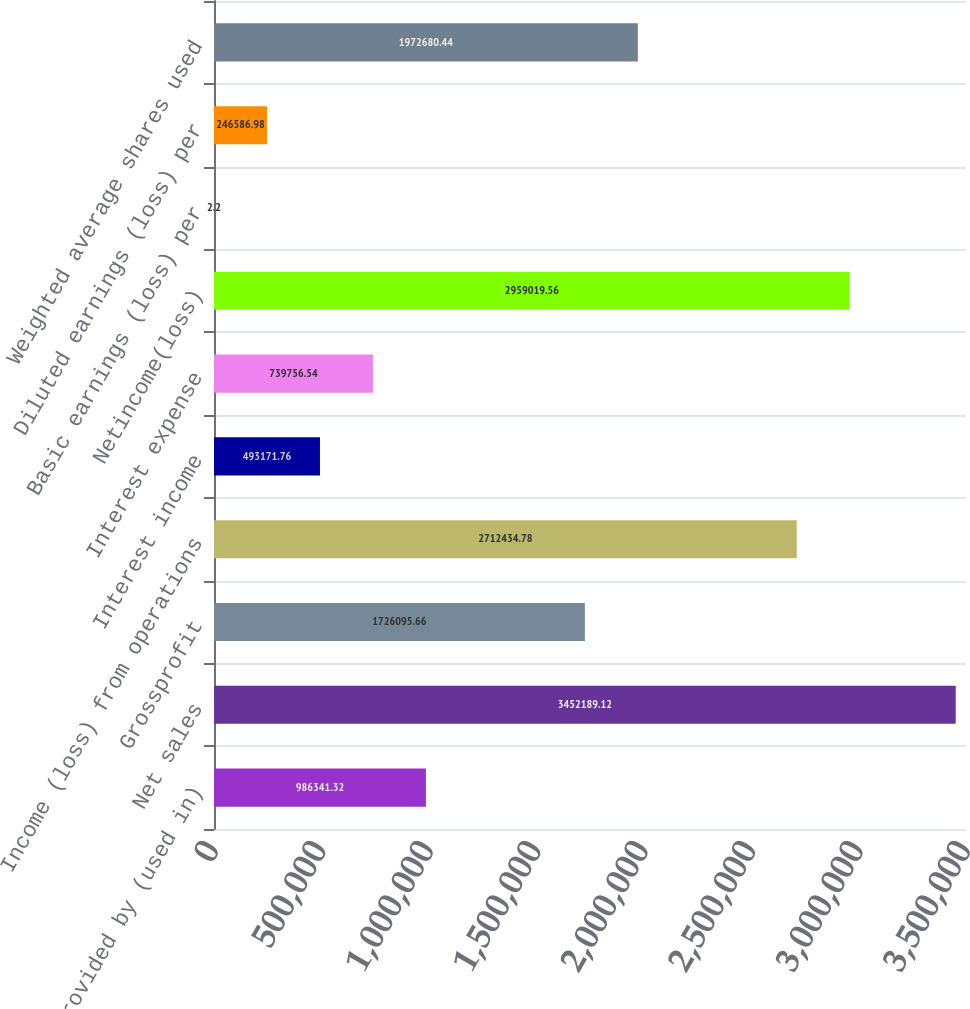Convert chart to OTSL. <chart><loc_0><loc_0><loc_500><loc_500><bar_chart><fcel>Net cash provided by (used in)<fcel>Net sales<fcel>Grossprofit<fcel>Income (loss) from operations<fcel>Interest income<fcel>Interest expense<fcel>Netincome(loss)<fcel>Basic earnings (loss) per<fcel>Diluted earnings (loss) per<fcel>Weighted average shares used<nl><fcel>986341<fcel>3.45219e+06<fcel>1.7261e+06<fcel>2.71243e+06<fcel>493172<fcel>739757<fcel>2.95902e+06<fcel>2.2<fcel>246587<fcel>1.97268e+06<nl></chart> 